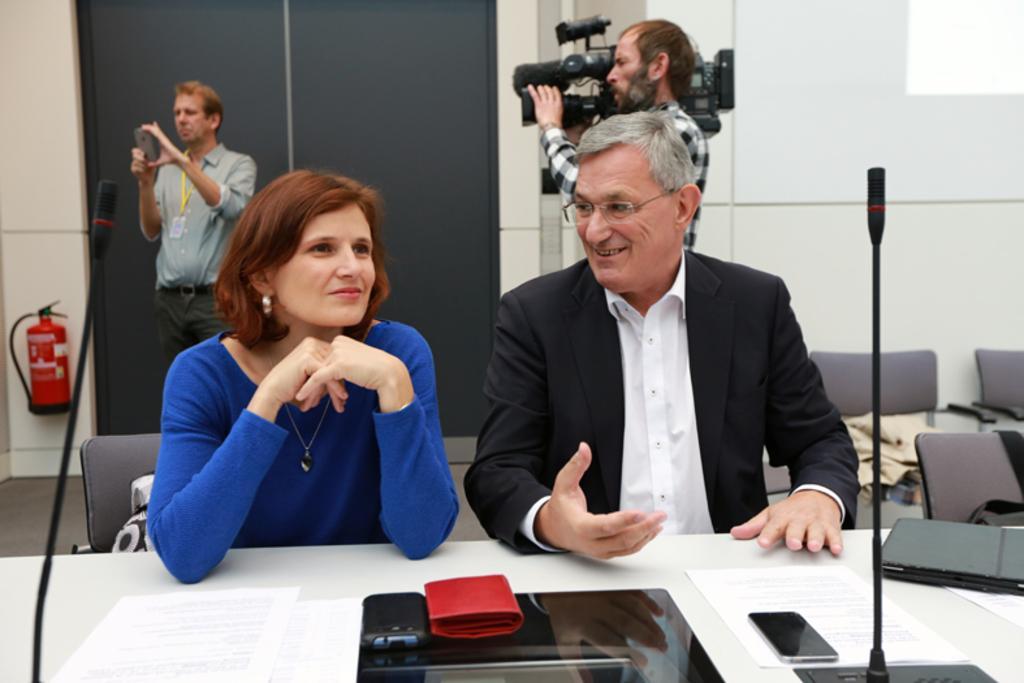In one or two sentences, can you explain what this image depicts? These two persons sitting on the chairs and smiling,these two persons are standing and this person holding camera. We can see microphones,papers,laptop,mobiles on the table. On the background we can see wall,chairs. 